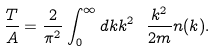Convert formula to latex. <formula><loc_0><loc_0><loc_500><loc_500>\frac { T } { A } = \frac { 2 } { \pi ^ { 2 } } \int _ { 0 } ^ { \infty } d k k ^ { 2 } \ \frac { k ^ { 2 } } { 2 m } n ( k ) .</formula> 